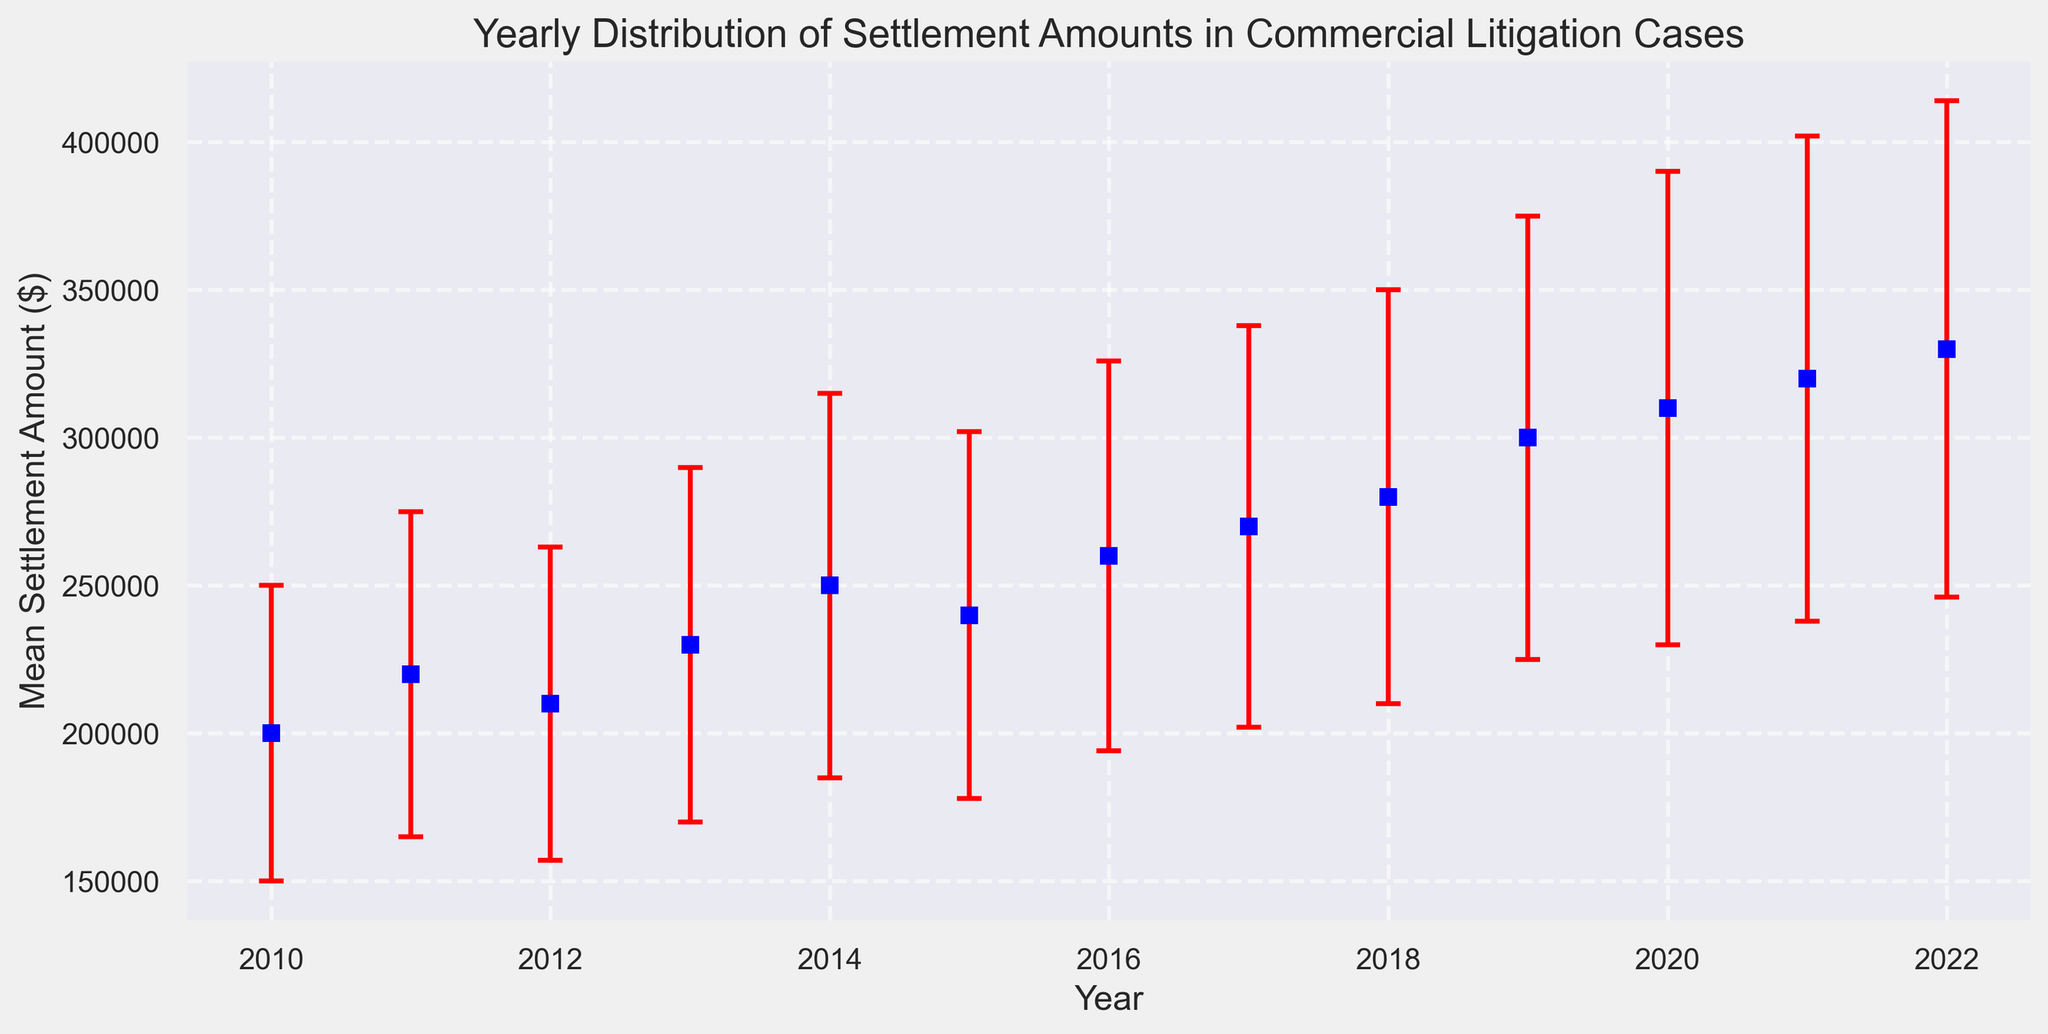What year had the highest mean settlement amount? By examining the figure, the year with the highest data point on the vertical axis indicates the highest mean settlement amount. We see that 2022 has the highest point.
Answer: 2022 How much did the mean settlement amount increase from 2010 to 2022? The mean settlement amount for 2010 is 200,000 and for 2022 is 330,000. Subtracting the values gives us the increase: 330,000 - 200,000 = 130,000.
Answer: 130,000 Which year had the highest standard deviation in settlement amounts? The red error bars represent the standard deviation. The longest error bar indicates the highest standard deviation, which is 2022 with an error bar of 84,000.
Answer: 2022 Is there a general trend in the mean settlement amounts over the years? Observing the data points over time, we see that mean settlement amounts generally increase from 2010 to 2022. This suggests a general upward trend.
Answer: Upward trend What is the difference in mean settlement amounts between 2015 and 2020? The mean settlement amount for 2015 is 240,000 and for 2020 is 310,000. The difference is 310,000 - 240,000 = 70,000.
Answer: 70,000 Which year has the smallest error bar and what does it represent? The year with the smallest red error bar is 2010, with a standard deviation of 50,000, representing the variability in settlement amounts for that year.
Answer: 2010, 50,000 Compare the mean settlement amounts between 2011 and 2013. Which year has a higher mean settlement amount and by how much? The mean settlement amount for 2011 is 220,000 and for 2013 is 230,000. The difference is 230,000 - 220,000 = 10,000, making 2013 higher by 10,000.
Answer: 2013, 10,000 What is the mean settlement amount for the middle year in the data set? The middle year in the data set is 2016. The mean settlement amount for 2016 is 260,000.
Answer: 260,000 What can be inferred about the consistency of settlement amounts in 2010 compared to 2022 from the plot? By comparing the length of the error bars, 2010 has a shorter error bar (indicating less variability) compared to 2022, which has a longer error bar. This implies settlements were more consistent in 2010.
Answer: More consistent in 2010 